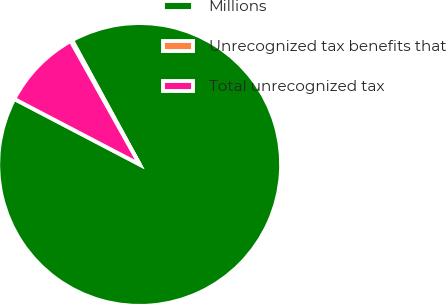Convert chart to OTSL. <chart><loc_0><loc_0><loc_500><loc_500><pie_chart><fcel>Millions<fcel>Unrecognized tax benefits that<fcel>Total unrecognized tax<nl><fcel>90.6%<fcel>0.18%<fcel>9.22%<nl></chart> 